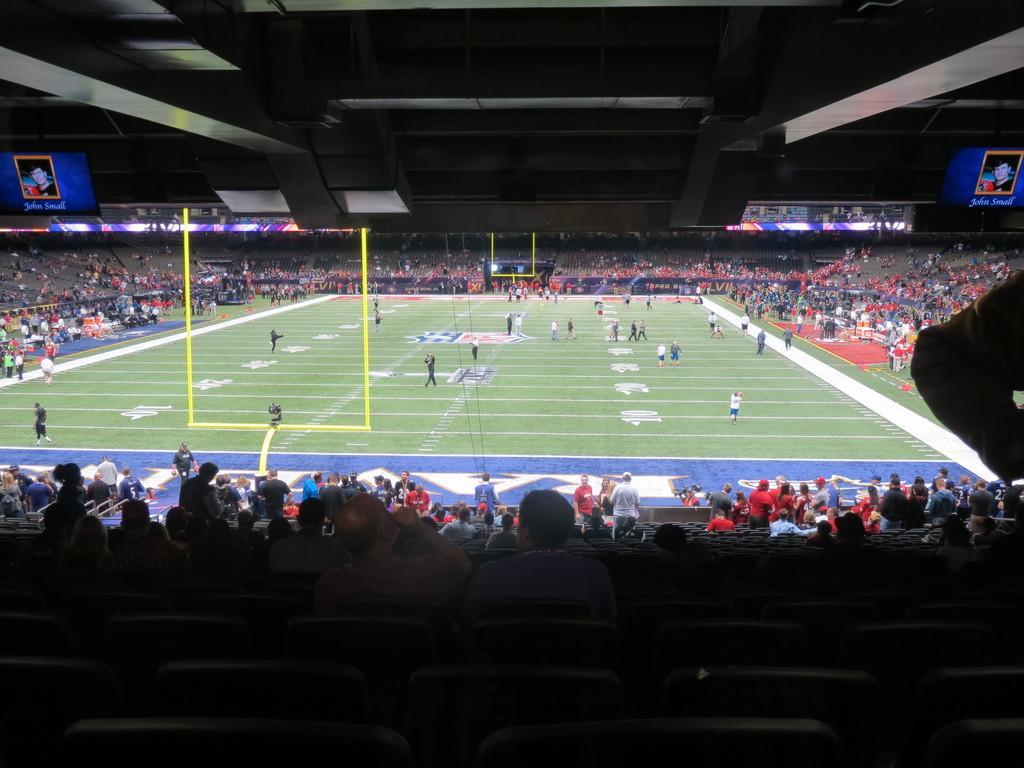Can you describe this image briefly? In this image I can see a stadium , in the stadium I can see a play ground and I can see yellow color rod and persons visible on middle and around the ground I can see crowd of people , at the top I can see the roof 